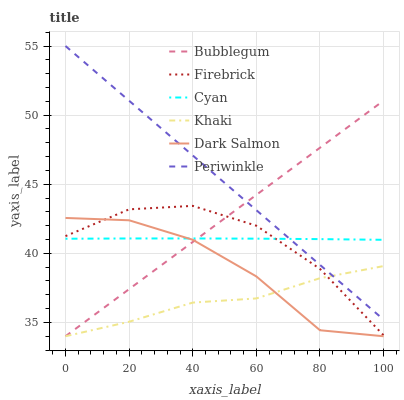Does Khaki have the minimum area under the curve?
Answer yes or no. Yes. Does Periwinkle have the maximum area under the curve?
Answer yes or no. Yes. Does Firebrick have the minimum area under the curve?
Answer yes or no. No. Does Firebrick have the maximum area under the curve?
Answer yes or no. No. Is Bubblegum the smoothest?
Answer yes or no. Yes. Is Dark Salmon the roughest?
Answer yes or no. Yes. Is Firebrick the smoothest?
Answer yes or no. No. Is Firebrick the roughest?
Answer yes or no. No. Does Khaki have the lowest value?
Answer yes or no. Yes. Does Firebrick have the lowest value?
Answer yes or no. No. Does Periwinkle have the highest value?
Answer yes or no. Yes. Does Firebrick have the highest value?
Answer yes or no. No. Is Khaki less than Cyan?
Answer yes or no. Yes. Is Cyan greater than Khaki?
Answer yes or no. Yes. Does Periwinkle intersect Khaki?
Answer yes or no. Yes. Is Periwinkle less than Khaki?
Answer yes or no. No. Is Periwinkle greater than Khaki?
Answer yes or no. No. Does Khaki intersect Cyan?
Answer yes or no. No. 